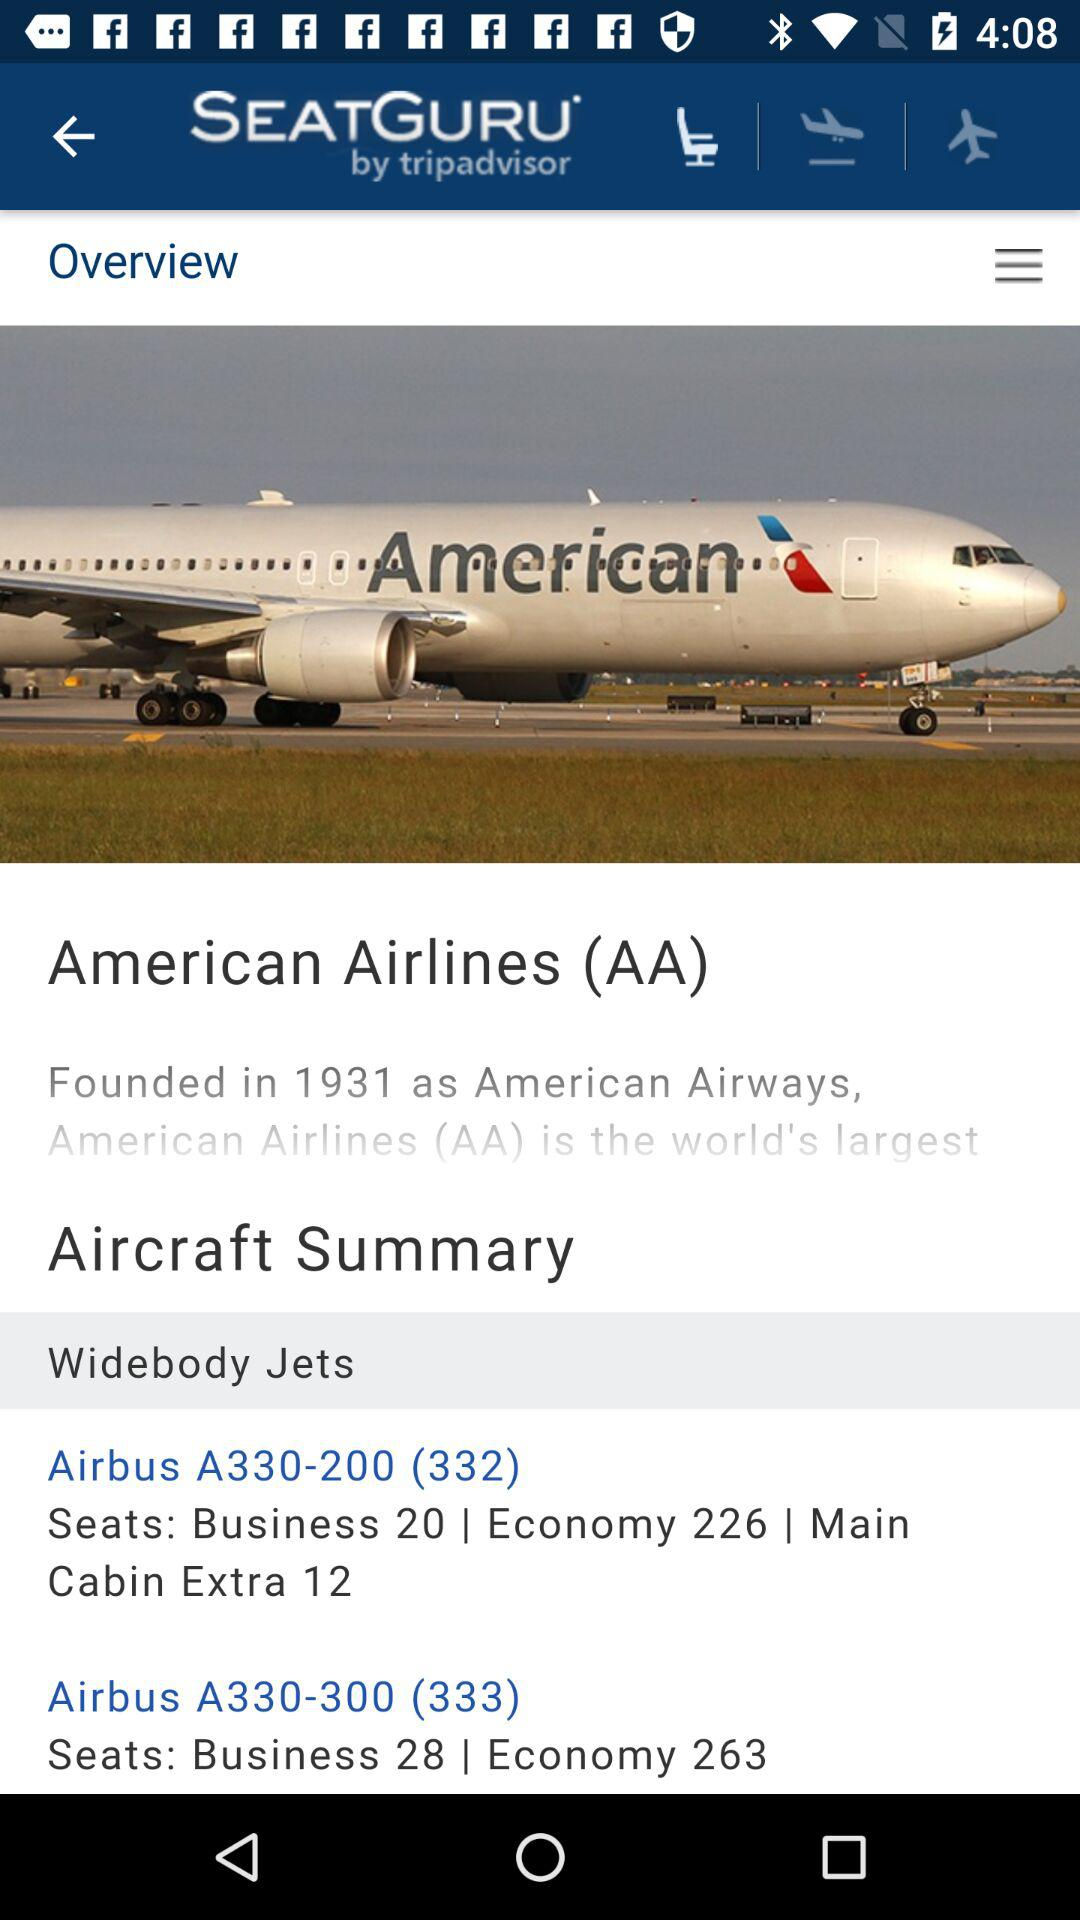What is the airline's name? The airline's name is "American Airlines (AA)". 